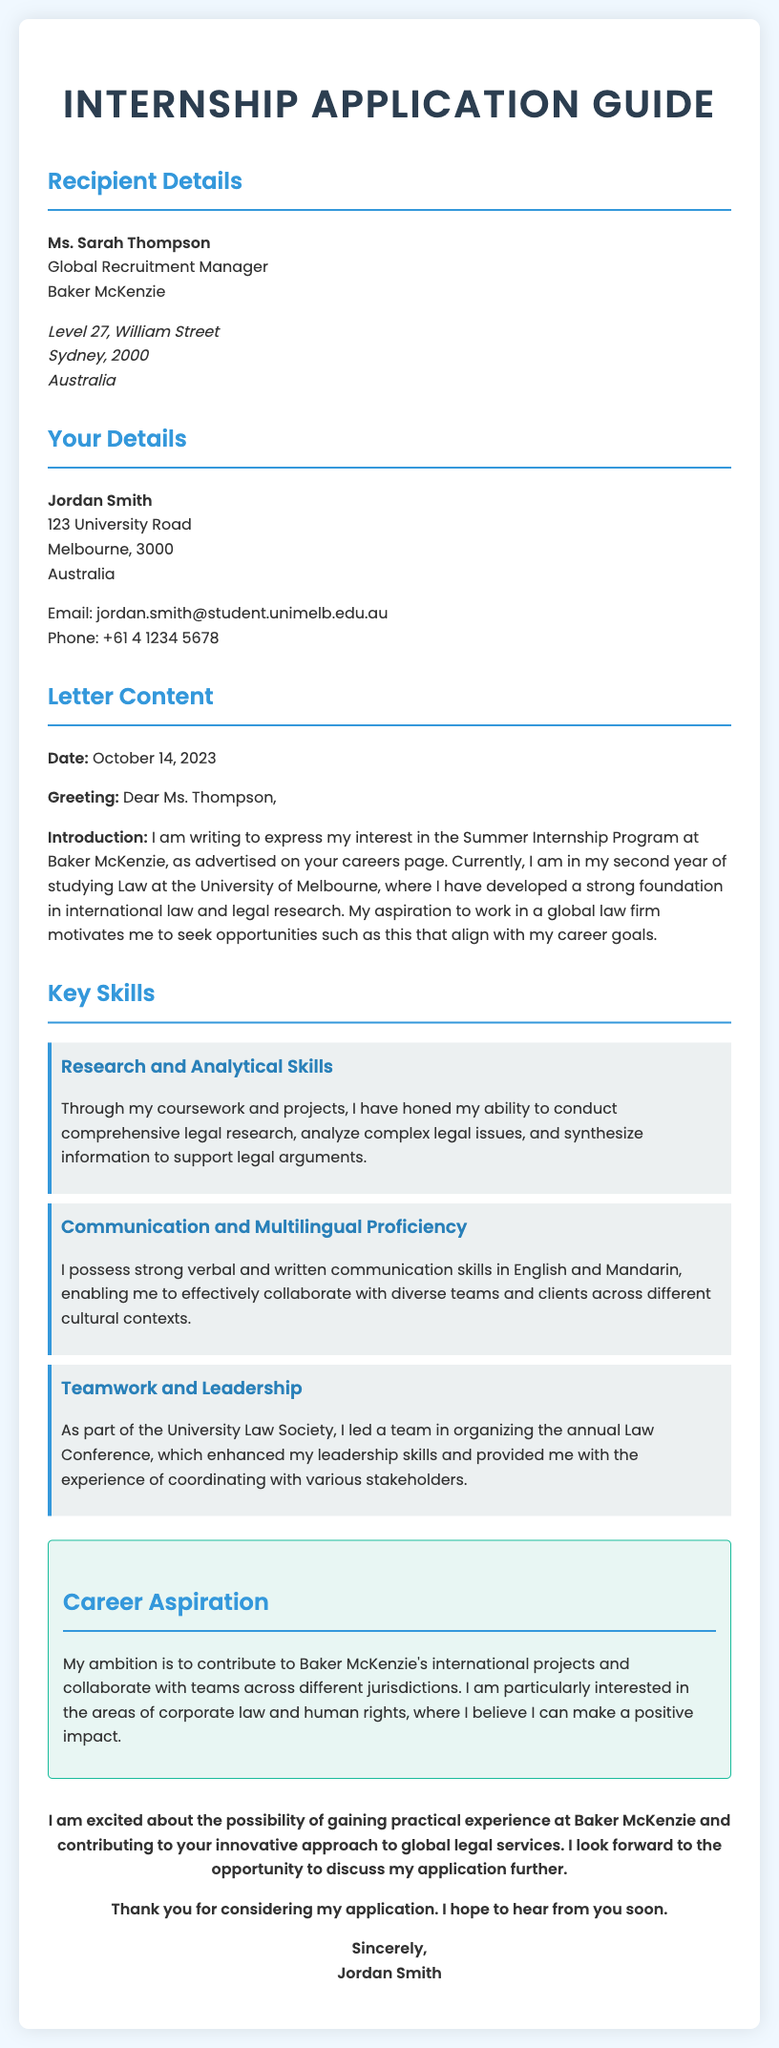What is the name of the recipient? The recipient's name is mentioned in the "Recipient Details" section of the document.
Answer: Ms. Sarah Thompson What is the name of the applicant? The applicant's name is provided in the "Your Details" section of the document.
Answer: Jordan Smith What is the date of the letter? The date is included in the "Letter Content" section of the document.
Answer: October 14, 2023 Which university is the applicant attending? The applicant's university is specified in the introduction of the letter.
Answer: University of Melbourne What area of law is the applicant particularly interested in? The applicant's areas of interest are outlined in the "Career Aspiration" section.
Answer: Corporate law and human rights What skill is highlighted first in the "Key Skills" section? The skills are listed sequentially; the first is detailed in the corresponding paragraph.
Answer: Research and Analytical Skills How many skills are listed in the "Key Skills" section? The skills mentioned collectively total up, and their count is specifically represented in the document.
Answer: Three What is the main motivation for the applicant to seek the internship? The motivation is described in the introduction of the letter regarding the applicant's aspirations.
Answer: To work in a global law firm What position does the recipient hold? The recipient's position is clearly stated in the "Recipient Details" section of the document.
Answer: Global Recruitment Manager 